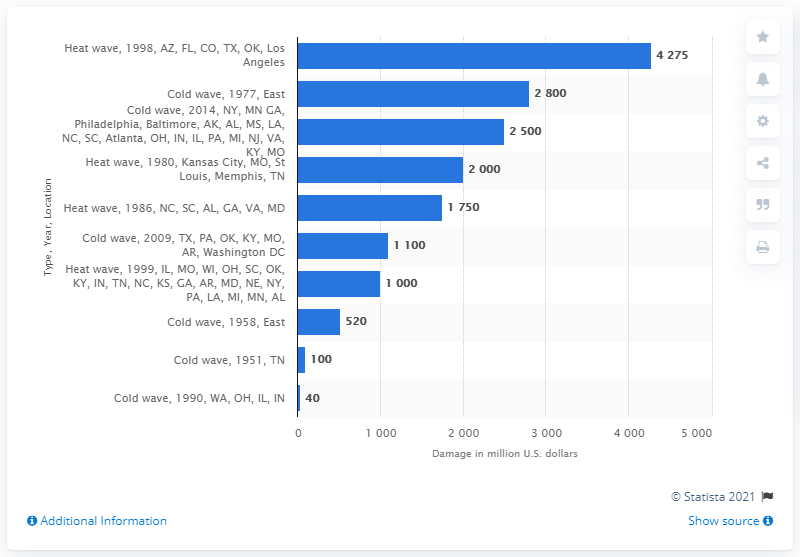Point out several critical features in this image. The cold wave that hit the East of the U.S. in 1977 caused an estimated damage of 2800. 